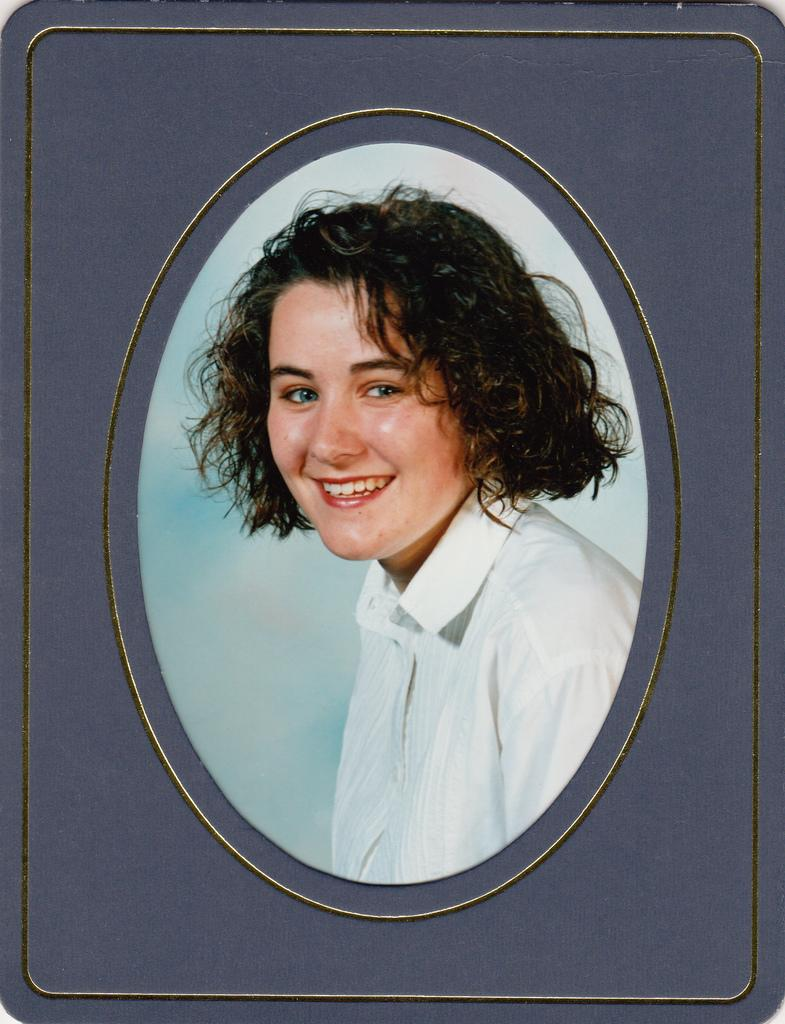Who is the main subject in the image? There is a girl in the photo frame in the image. Can you describe the girl's appearance or any details about her? Unfortunately, the image only shows the girl in the photo frame, and no additional details about her appearance are provided. What type of spy equipment can be seen in the image? There is no spy equipment present in the image; it only features a girl in a photo frame. 